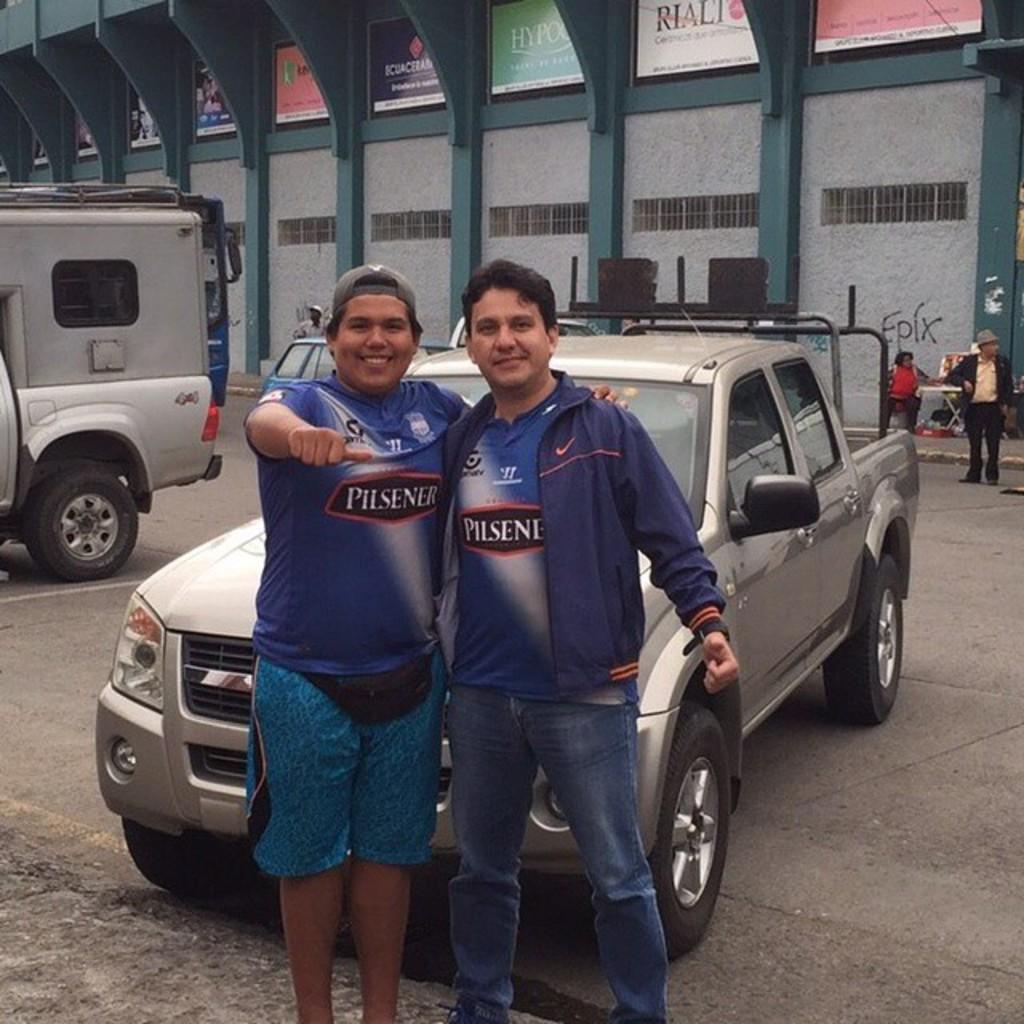Can you describe this image briefly? In this image we can see few persons, there are some vehicles on the road, also we can see a building, pillars, boards with some text written on it. 